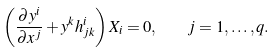Convert formula to latex. <formula><loc_0><loc_0><loc_500><loc_500>\left ( \frac { \partial y ^ { i } } { \partial x ^ { j } } + y ^ { k } h _ { j k } ^ { i } \right ) X _ { i } = 0 , \quad j = 1 , \dots , q .</formula> 